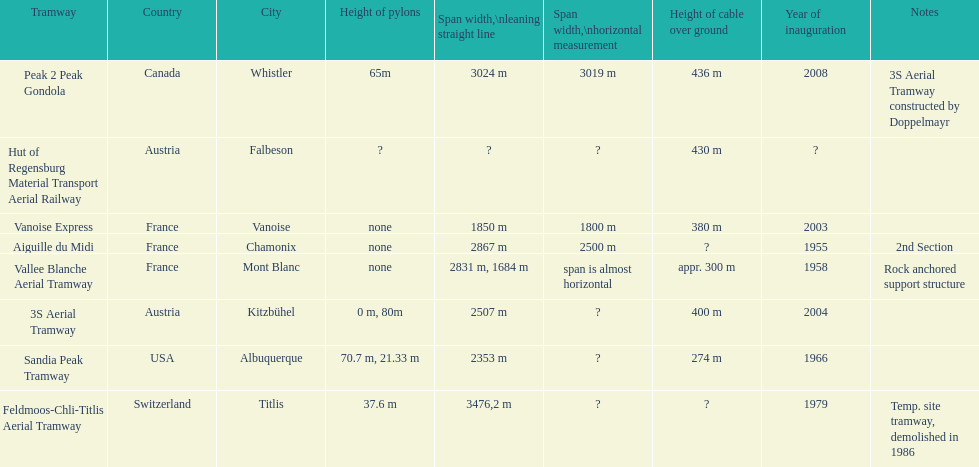Was the peak 2 peak gondola inaugurated before the vanoise express? No. 